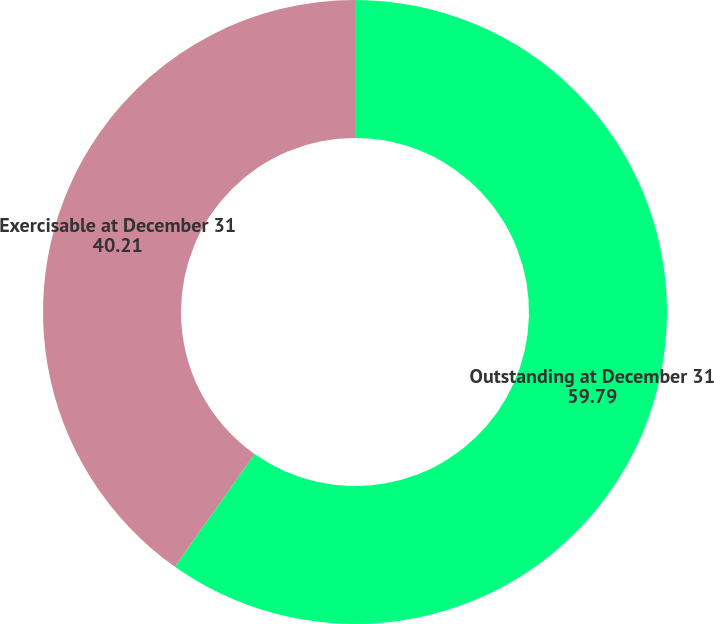<chart> <loc_0><loc_0><loc_500><loc_500><pie_chart><fcel>Outstanding at December 31<fcel>Exercisable at December 31<nl><fcel>59.79%<fcel>40.21%<nl></chart> 